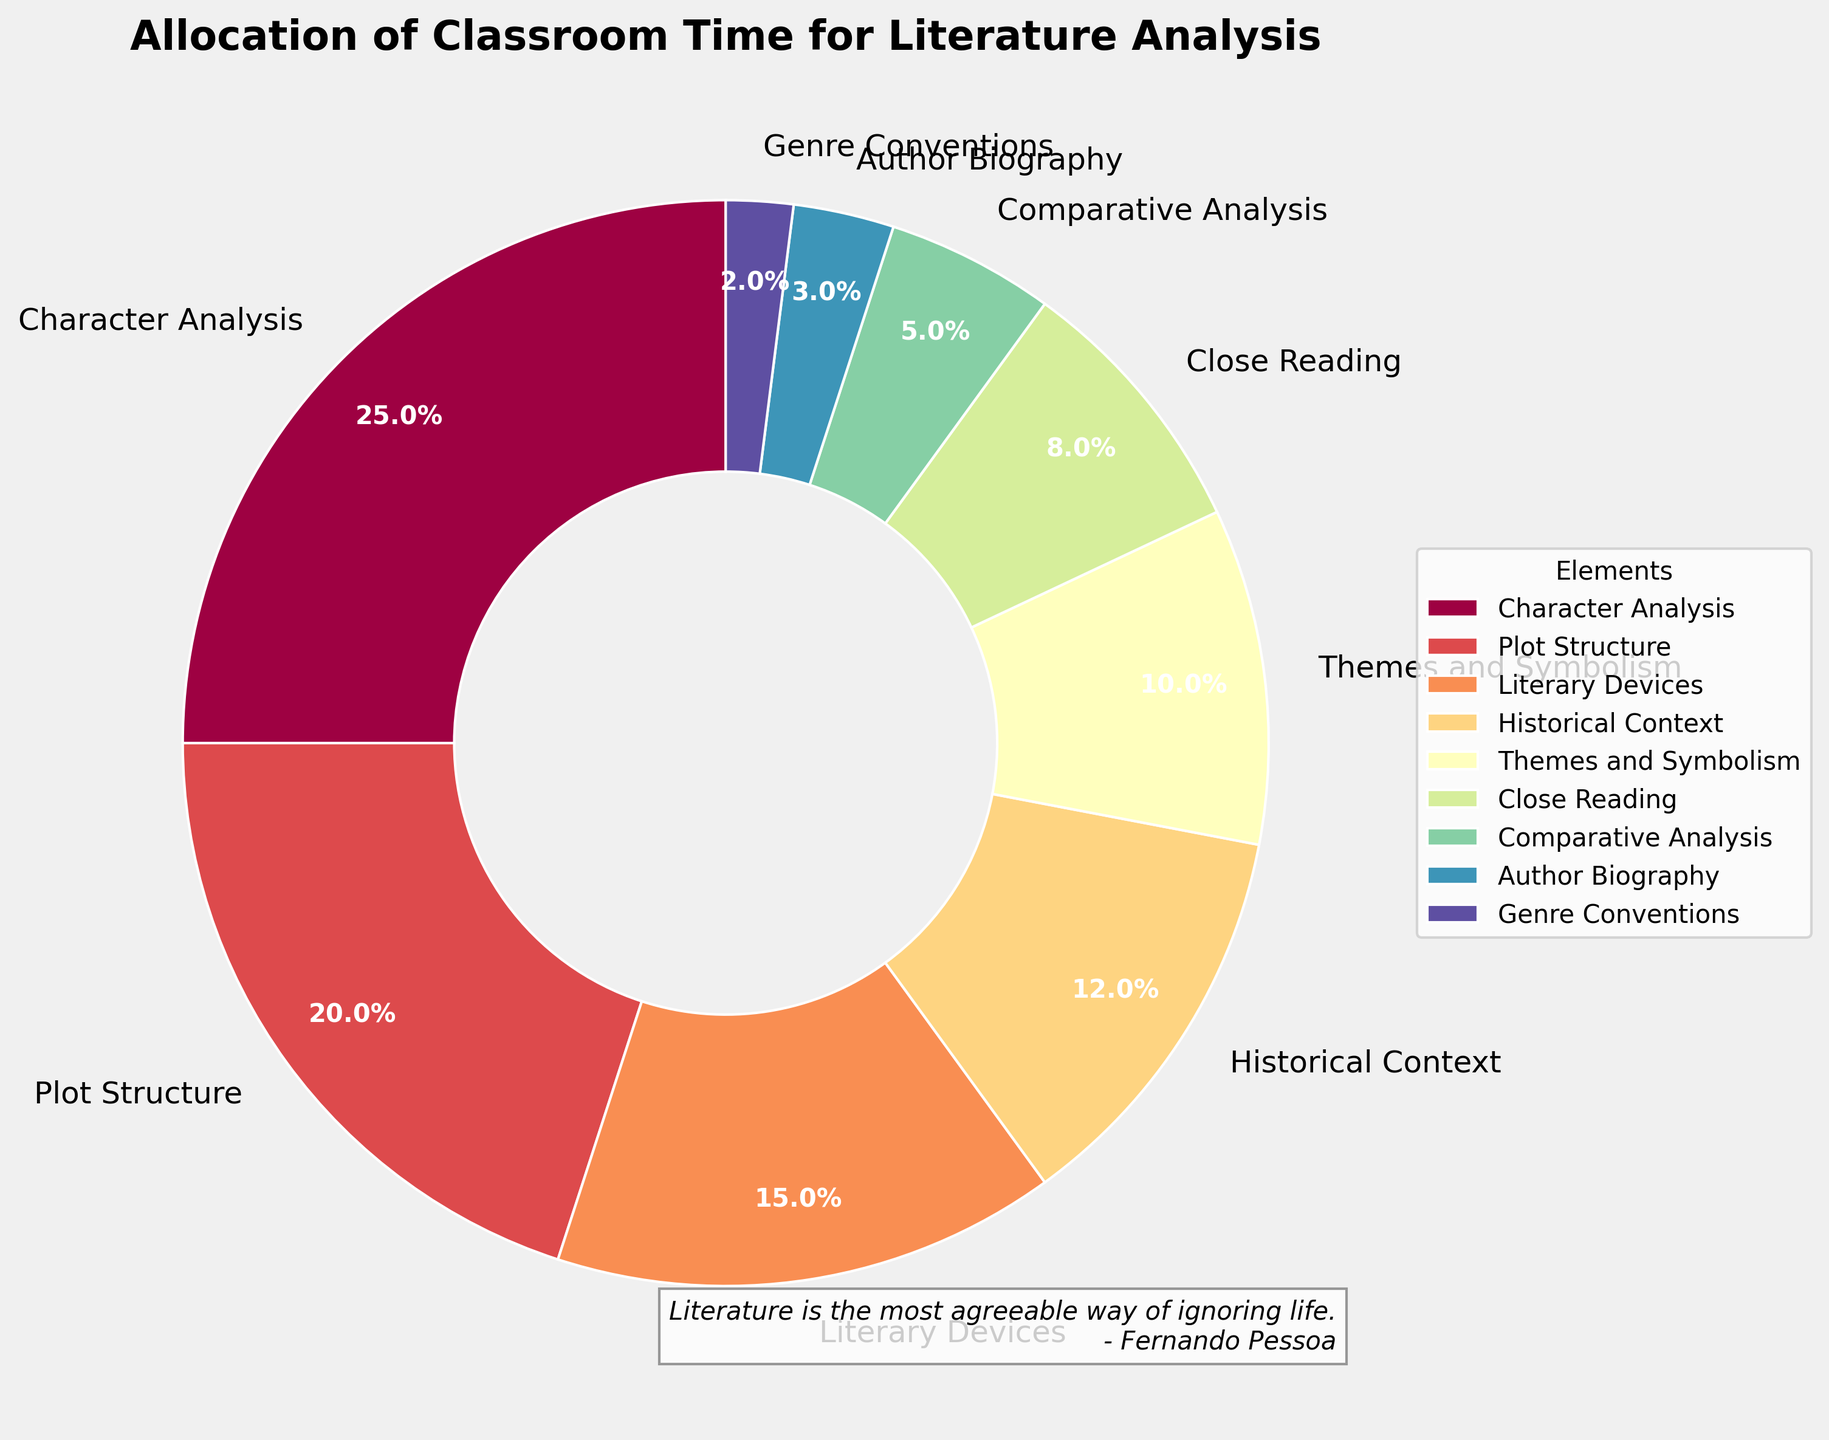What percentage of classroom time is allocated to Literary Devices and Historical Context combined? The portion allocated to Literary Devices is 15%, and Historical Context is 12%. Adding these percentages together gives 15% + 12% = 27%.
Answer: 27% Which literature analysis element is given the most classroom time? By examining the figure, we see that Character Analysis occupies the largest segment of the pie chart.
Answer: Character Analysis How much more time is spent on Character Analysis compared to Themes and Symbolism? The figure shows that Character Analysis takes up 25% of the time, while Themes and Symbolism takes up 10%. Subtracting these gives 25% - 10% = 15%.
Answer: 15% What is the least allocated element in terms of classroom time, and what percentage of time is it given? By looking at the smallest segment of the pie chart, we can see that Genre Conventions receives the least amount of time, which is 2%.
Answer: Genre Conventions, 2% Rank the top three elements in terms of time allocation from highest to lowest. From the pie chart, the largest segments correspond to Character Analysis (25%), Plot Structure (20%), and Literary Devices (15%).
Answer: Character Analysis, Plot Structure, Literary Devices Calculate the total percentage of time spent on Comparative Analysis, Author Biography, and Genre Conventions. Adding the percentages for these elements: Comparative Analysis (5%) + Author Biography (3%) + Genre Conventions (2%) = 5% + 3% + 2% = 10%.
Answer: 10% Is more classroom time spent on Comparative Analysis or Close Reading? The pie chart shows that Comparative Analysis occupies 5% of the time, whereas Close Reading occupies 8%. Therefore, more time is spent on Close Reading.
Answer: Close Reading What percentage of classroom time is dedicated to both Plot Structure and Themes and Symbolism together? Adding the percentages for Plot Structure (20%) and Themes and Symbolism (10%): 20% + 10% = 30%.
Answer: 30% Which element is visually represented using the brightest color in the pie chart? By inspecting the pie chart, the brightest color corresponds to Character Analysis, as it usually attracts the most attention with a vivid color.
Answer: Character Analysis 